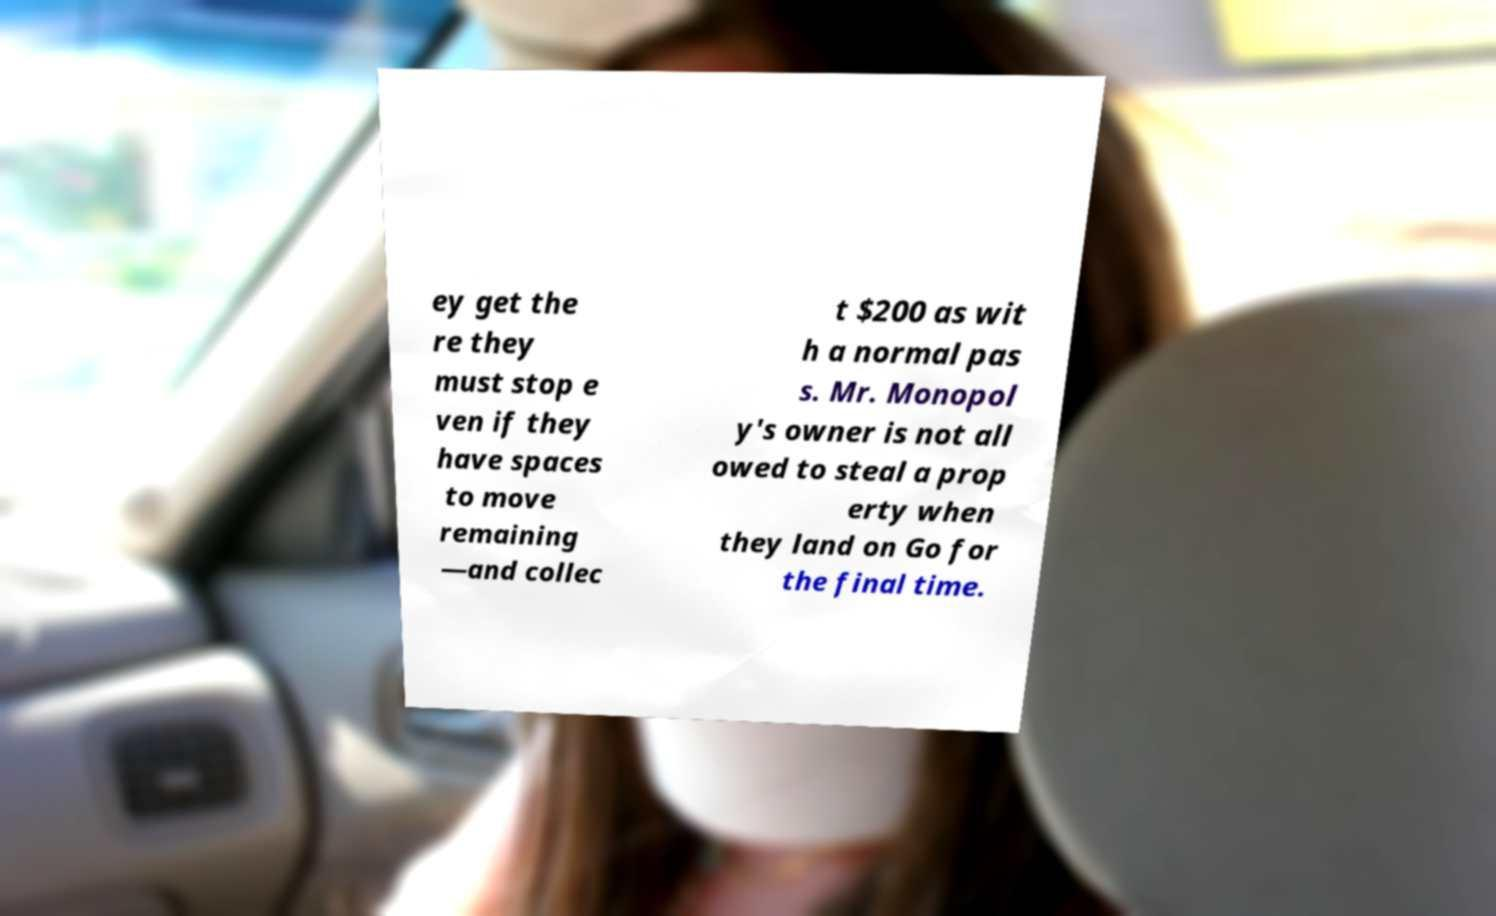Please read and relay the text visible in this image. What does it say? ey get the re they must stop e ven if they have spaces to move remaining —and collec t $200 as wit h a normal pas s. Mr. Monopol y's owner is not all owed to steal a prop erty when they land on Go for the final time. 